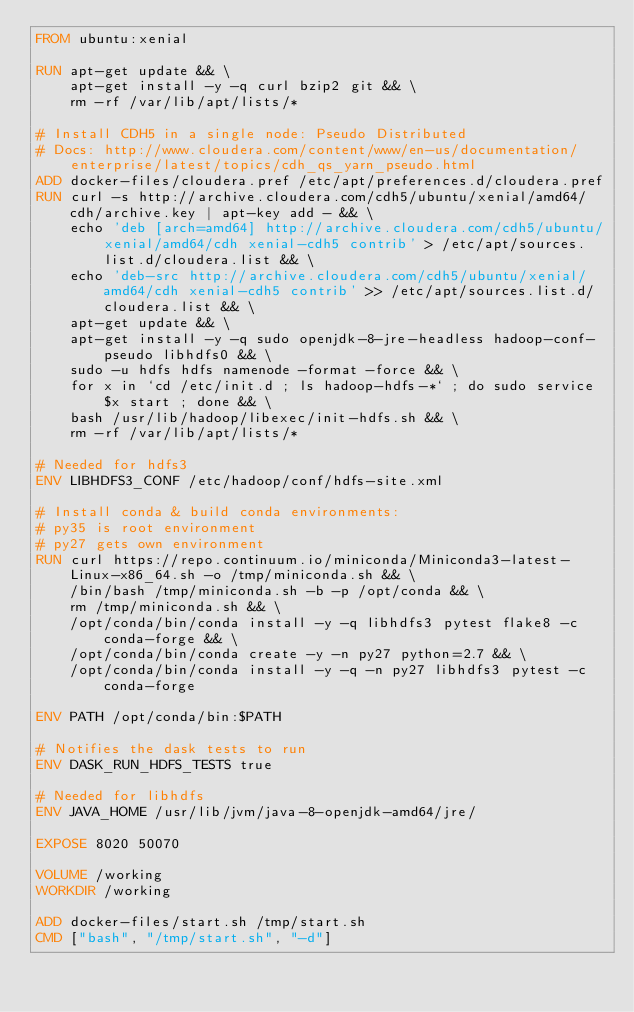Convert code to text. <code><loc_0><loc_0><loc_500><loc_500><_Dockerfile_>FROM ubuntu:xenial

RUN apt-get update && \
    apt-get install -y -q curl bzip2 git && \
    rm -rf /var/lib/apt/lists/*

# Install CDH5 in a single node: Pseudo Distributed
# Docs: http://www.cloudera.com/content/www/en-us/documentation/enterprise/latest/topics/cdh_qs_yarn_pseudo.html
ADD docker-files/cloudera.pref /etc/apt/preferences.d/cloudera.pref
RUN curl -s http://archive.cloudera.com/cdh5/ubuntu/xenial/amd64/cdh/archive.key | apt-key add - && \
    echo 'deb [arch=amd64] http://archive.cloudera.com/cdh5/ubuntu/xenial/amd64/cdh xenial-cdh5 contrib' > /etc/apt/sources.list.d/cloudera.list && \
    echo 'deb-src http://archive.cloudera.com/cdh5/ubuntu/xenial/amd64/cdh xenial-cdh5 contrib' >> /etc/apt/sources.list.d/cloudera.list && \
    apt-get update && \
    apt-get install -y -q sudo openjdk-8-jre-headless hadoop-conf-pseudo libhdfs0 && \
    sudo -u hdfs hdfs namenode -format -force && \
    for x in `cd /etc/init.d ; ls hadoop-hdfs-*` ; do sudo service $x start ; done && \
    bash /usr/lib/hadoop/libexec/init-hdfs.sh && \
    rm -rf /var/lib/apt/lists/*

# Needed for hdfs3
ENV LIBHDFS3_CONF /etc/hadoop/conf/hdfs-site.xml

# Install conda & build conda environments:
# py35 is root environment
# py27 gets own environment
RUN curl https://repo.continuum.io/miniconda/Miniconda3-latest-Linux-x86_64.sh -o /tmp/miniconda.sh && \
    /bin/bash /tmp/miniconda.sh -b -p /opt/conda && \
    rm /tmp/miniconda.sh && \
    /opt/conda/bin/conda install -y -q libhdfs3 pytest flake8 -c conda-forge && \
    /opt/conda/bin/conda create -y -n py27 python=2.7 && \
    /opt/conda/bin/conda install -y -q -n py27 libhdfs3 pytest -c conda-forge

ENV PATH /opt/conda/bin:$PATH

# Notifies the dask tests to run
ENV DASK_RUN_HDFS_TESTS true

# Needed for libhdfs
ENV JAVA_HOME /usr/lib/jvm/java-8-openjdk-amd64/jre/

EXPOSE 8020 50070

VOLUME /working
WORKDIR /working

ADD docker-files/start.sh /tmp/start.sh
CMD ["bash", "/tmp/start.sh", "-d"]
</code> 